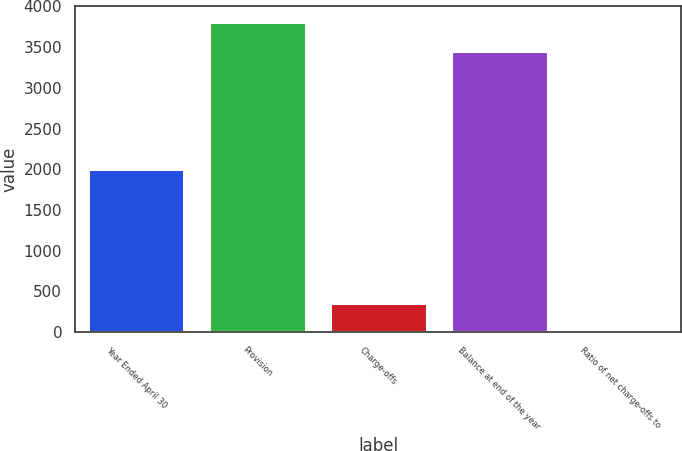<chart> <loc_0><loc_0><loc_500><loc_500><bar_chart><fcel>Year Ended April 30<fcel>Provision<fcel>Charge-offs<fcel>Balance at end of the year<fcel>Ratio of net charge-offs to<nl><fcel>2007<fcel>3810.2<fcel>362.22<fcel>3448<fcel>0.02<nl></chart> 